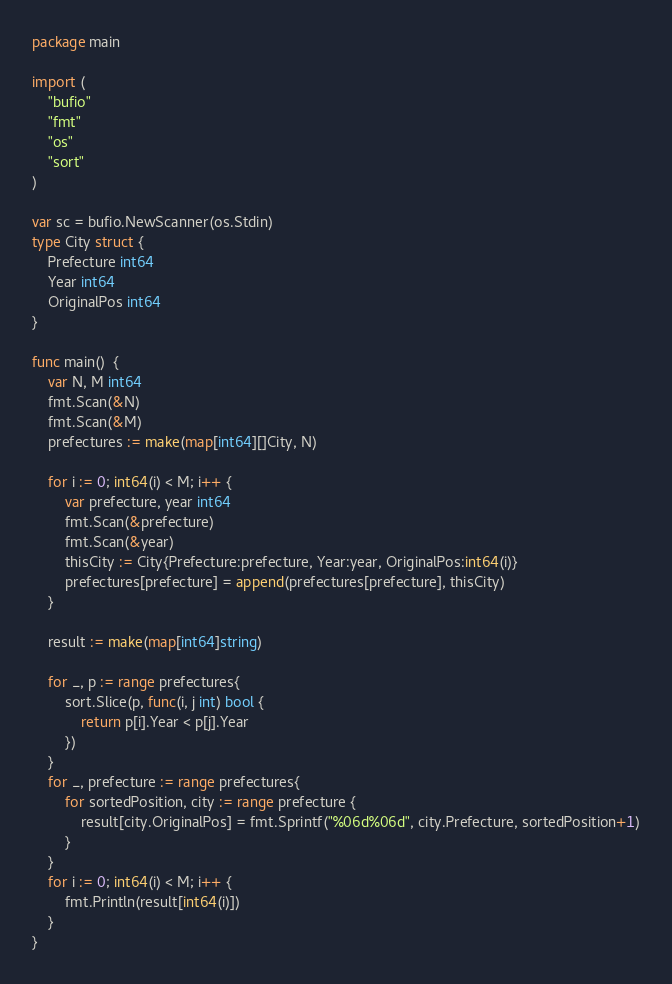<code> <loc_0><loc_0><loc_500><loc_500><_Go_>package main

import (
	"bufio"
	"fmt"
	"os"
	"sort"
)

var sc = bufio.NewScanner(os.Stdin)
type City struct {
	Prefecture int64
	Year int64
	OriginalPos int64
}

func main()  {
	var N, M int64
	fmt.Scan(&N)
	fmt.Scan(&M)
	prefectures := make(map[int64][]City, N)

	for i := 0; int64(i) < M; i++ {
		var prefecture, year int64
		fmt.Scan(&prefecture)
		fmt.Scan(&year)
		thisCity := City{Prefecture:prefecture, Year:year, OriginalPos:int64(i)}
		prefectures[prefecture] = append(prefectures[prefecture], thisCity)
	}

	result := make(map[int64]string)

	for _, p := range prefectures{
		sort.Slice(p, func(i, j int) bool {
			return p[i].Year < p[j].Year
		})
	}
	for _, prefecture := range prefectures{
		for sortedPosition, city := range prefecture {
			result[city.OriginalPos] = fmt.Sprintf("%06d%06d", city.Prefecture, sortedPosition+1)
		}
	}
	for i := 0; int64(i) < M; i++ {
		fmt.Println(result[int64(i)])
	}
}

</code> 